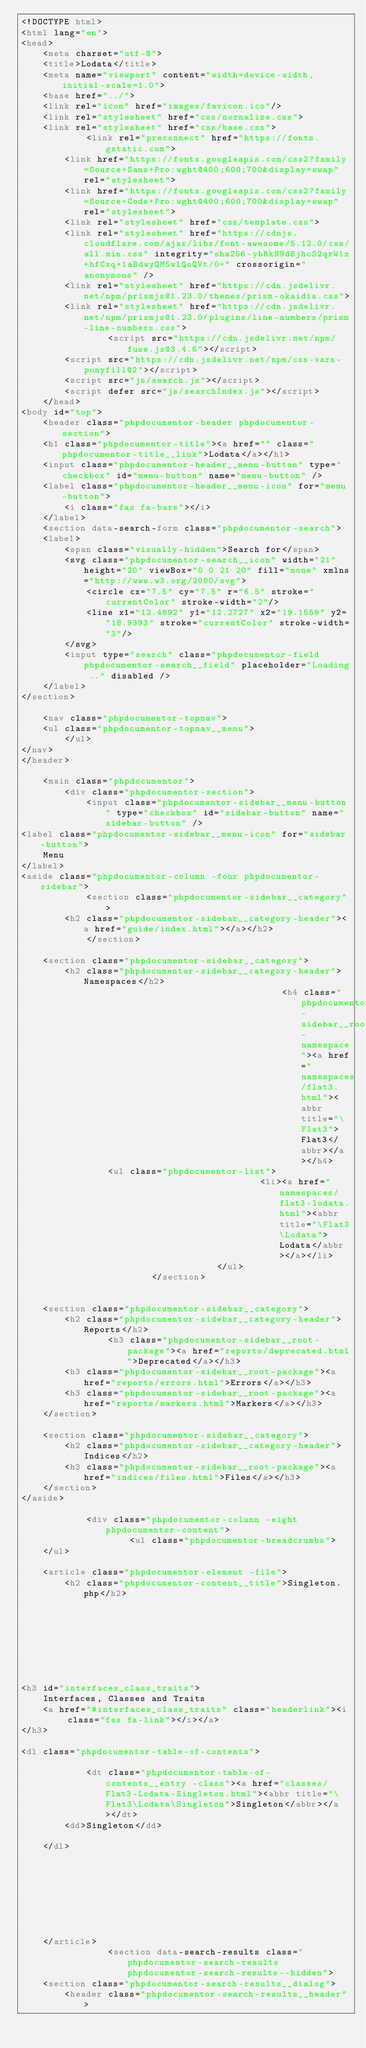<code> <loc_0><loc_0><loc_500><loc_500><_HTML_><!DOCTYPE html>
<html lang="en">
<head>
    <meta charset="utf-8">
    <title>Lodata</title>
    <meta name="viewport" content="width=device-width, initial-scale=1.0">
    <base href="../">
    <link rel="icon" href="images/favicon.ico"/>
    <link rel="stylesheet" href="css/normalize.css">
    <link rel="stylesheet" href="css/base.css">
            <link rel="preconnect" href="https://fonts.gstatic.com">
        <link href="https://fonts.googleapis.com/css2?family=Source+Sans+Pro:wght@400;600;700&display=swap" rel="stylesheet">
        <link href="https://fonts.googleapis.com/css2?family=Source+Code+Pro:wght@400;600;700&display=swap" rel="stylesheet">
        <link rel="stylesheet" href="css/template.css">
        <link rel="stylesheet" href="https://cdnjs.cloudflare.com/ajax/libs/font-awesome/5.12.0/css/all.min.css" integrity="sha256-ybRkN9dBjhcS2qrW1z+hfCxq+1aBdwyQM5wlQoQVt/0=" crossorigin="anonymous" />
        <link rel="stylesheet" href="https://cdn.jsdelivr.net/npm/prismjs@1.23.0/themes/prism-okaidia.css">
        <link rel="stylesheet" href="https://cdn.jsdelivr.net/npm/prismjs@1.23.0/plugins/line-numbers/prism-line-numbers.css">
                <script src="https://cdn.jsdelivr.net/npm/fuse.js@3.4.6"></script>
        <script src="https://cdn.jsdelivr.net/npm/css-vars-ponyfill@2"></script>
        <script src="js/search.js"></script>
        <script defer src="js/searchIndex.js"></script>
    </head>
<body id="top">
    <header class="phpdocumentor-header phpdocumentor-section">
    <h1 class="phpdocumentor-title"><a href="" class="phpdocumentor-title__link">Lodata</a></h1>
    <input class="phpdocumentor-header__menu-button" type="checkbox" id="menu-button" name="menu-button" />
    <label class="phpdocumentor-header__menu-icon" for="menu-button">
        <i class="fas fa-bars"></i>
    </label>
    <section data-search-form class="phpdocumentor-search">
    <label>
        <span class="visually-hidden">Search for</span>
        <svg class="phpdocumentor-search__icon" width="21" height="20" viewBox="0 0 21 20" fill="none" xmlns="http://www.w3.org/2000/svg">
            <circle cx="7.5" cy="7.5" r="6.5" stroke="currentColor" stroke-width="2"/>
            <line x1="12.4892" y1="12.2727" x2="19.1559" y2="18.9393" stroke="currentColor" stroke-width="3"/>
        </svg>
        <input type="search" class="phpdocumentor-field phpdocumentor-search__field" placeholder="Loading .." disabled />
    </label>
</section>

    <nav class="phpdocumentor-topnav">
    <ul class="phpdocumentor-topnav__menu">
        </ul>
</nav>
</header>

    <main class="phpdocumentor">
        <div class="phpdocumentor-section">
            <input class="phpdocumentor-sidebar__menu-button" type="checkbox" id="sidebar-button" name="sidebar-button" />
<label class="phpdocumentor-sidebar__menu-icon" for="sidebar-button">
    Menu
</label>
<aside class="phpdocumentor-column -four phpdocumentor-sidebar">
            <section class="phpdocumentor-sidebar__category">
        <h2 class="phpdocumentor-sidebar__category-header"><a href="guide/index.html"></a></h2>
            </section>
    
    <section class="phpdocumentor-sidebar__category">
        <h2 class="phpdocumentor-sidebar__category-header">Namespaces</h2>
                                                <h4 class="phpdocumentor-sidebar__root-namespace"><a href="namespaces/flat3.html"><abbr title="\Flat3">Flat3</abbr></a></h4>
                <ul class="phpdocumentor-list">
                                            <li><a href="namespaces/flat3-lodata.html"><abbr title="\Flat3\Lodata">Lodata</abbr></a></li>
                                    </ul>
                        </section>

    
    <section class="phpdocumentor-sidebar__category">
        <h2 class="phpdocumentor-sidebar__category-header">Reports</h2>
                <h3 class="phpdocumentor-sidebar__root-package"><a href="reports/deprecated.html">Deprecated</a></h3>
        <h3 class="phpdocumentor-sidebar__root-package"><a href="reports/errors.html">Errors</a></h3>
        <h3 class="phpdocumentor-sidebar__root-package"><a href="reports/markers.html">Markers</a></h3>
    </section>

    <section class="phpdocumentor-sidebar__category">
        <h2 class="phpdocumentor-sidebar__category-header">Indices</h2>
        <h3 class="phpdocumentor-sidebar__root-package"><a href="indices/files.html">Files</a></h3>
    </section>
</aside>

            <div class="phpdocumentor-column -eight phpdocumentor-content">
                    <ul class="phpdocumentor-breadcrumbs">
    </ul>

    <article class="phpdocumentor-element -file">
        <h2 class="phpdocumentor-content__title">Singleton.php</h2>

        






<h3 id="interfaces_class_traits">
    Interfaces, Classes and Traits
    <a href="#interfaces_class_traits" class="headerlink"><i class="fas fa-link"></i></a>
</h3>

<dl class="phpdocumentor-table-of-contents">
    
            <dt class="phpdocumentor-table-of-contents__entry -class"><a href="classes/Flat3-Lodata-Singleton.html"><abbr title="\Flat3\Lodata\Singleton">Singleton</abbr></a></dt>
        <dd>Singleton</dd>
    
    </dl>





        

        
    </article>
                <section data-search-results class="phpdocumentor-search-results phpdocumentor-search-results--hidden">
    <section class="phpdocumentor-search-results__dialog">
        <header class="phpdocumentor-search-results__header"></code> 